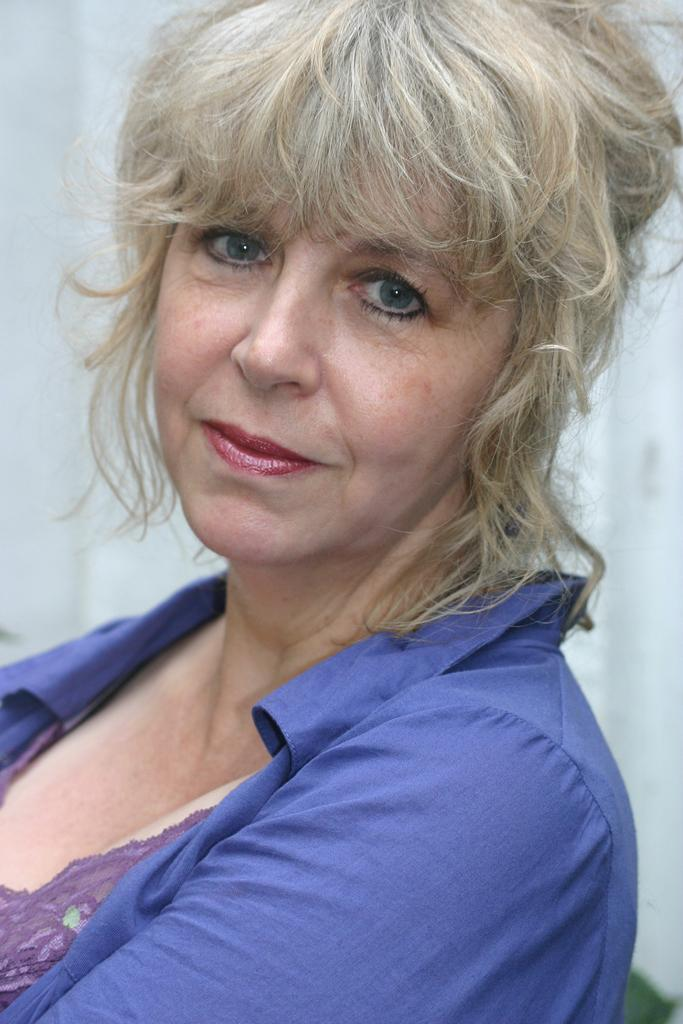What is the main subject of the image? The main subject of the image is a woman. What is the woman wearing in the image? The woman is wearing a blue shirt. What can be seen behind the woman in the image? There is a wall visible behind the woman in the image. What type of metal is the woman holding in her hands in the image? There is no metal object visible in the woman's hands in the image. What town is visible in the background of the image? There is no town visible in the image; it only shows a woman and a wall in the background. 